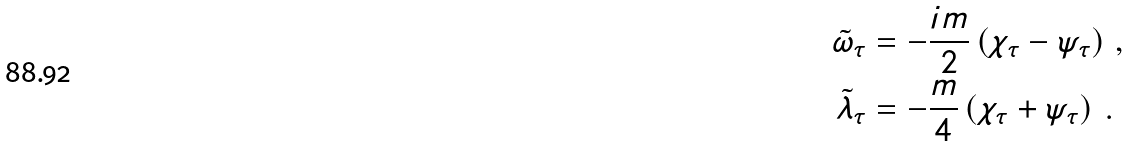<formula> <loc_0><loc_0><loc_500><loc_500>\tilde { \omega } _ { \tau } & = - \frac { i m } { 2 } \left ( \chi _ { \tau } - \psi _ { \tau } \right ) \, , \\ \tilde { \lambda } _ { \tau } & = - \frac { m } { 4 } \left ( \chi _ { \tau } + \psi _ { \tau } \right ) \, .</formula> 